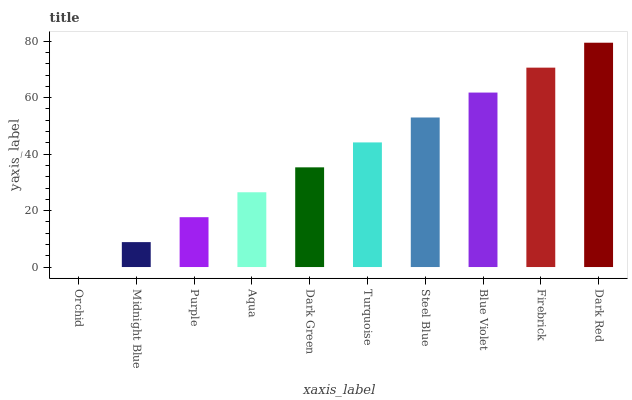Is Midnight Blue the minimum?
Answer yes or no. No. Is Midnight Blue the maximum?
Answer yes or no. No. Is Midnight Blue greater than Orchid?
Answer yes or no. Yes. Is Orchid less than Midnight Blue?
Answer yes or no. Yes. Is Orchid greater than Midnight Blue?
Answer yes or no. No. Is Midnight Blue less than Orchid?
Answer yes or no. No. Is Turquoise the high median?
Answer yes or no. Yes. Is Dark Green the low median?
Answer yes or no. Yes. Is Dark Green the high median?
Answer yes or no. No. Is Dark Red the low median?
Answer yes or no. No. 